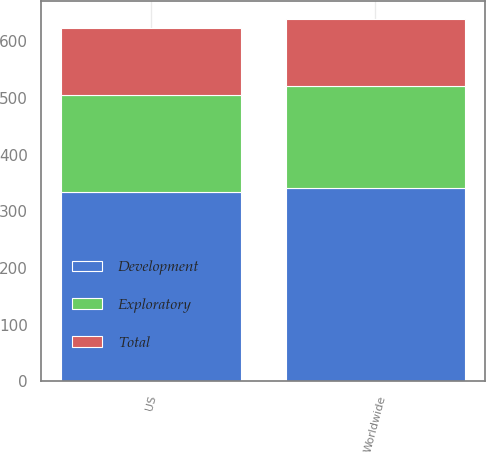Convert chart. <chart><loc_0><loc_0><loc_500><loc_500><stacked_bar_chart><ecel><fcel>US<fcel>Worldwide<nl><fcel>Exploratory<fcel>172<fcel>179<nl><fcel>Total<fcel>117<fcel>118<nl><fcel>Development<fcel>334<fcel>342<nl></chart> 